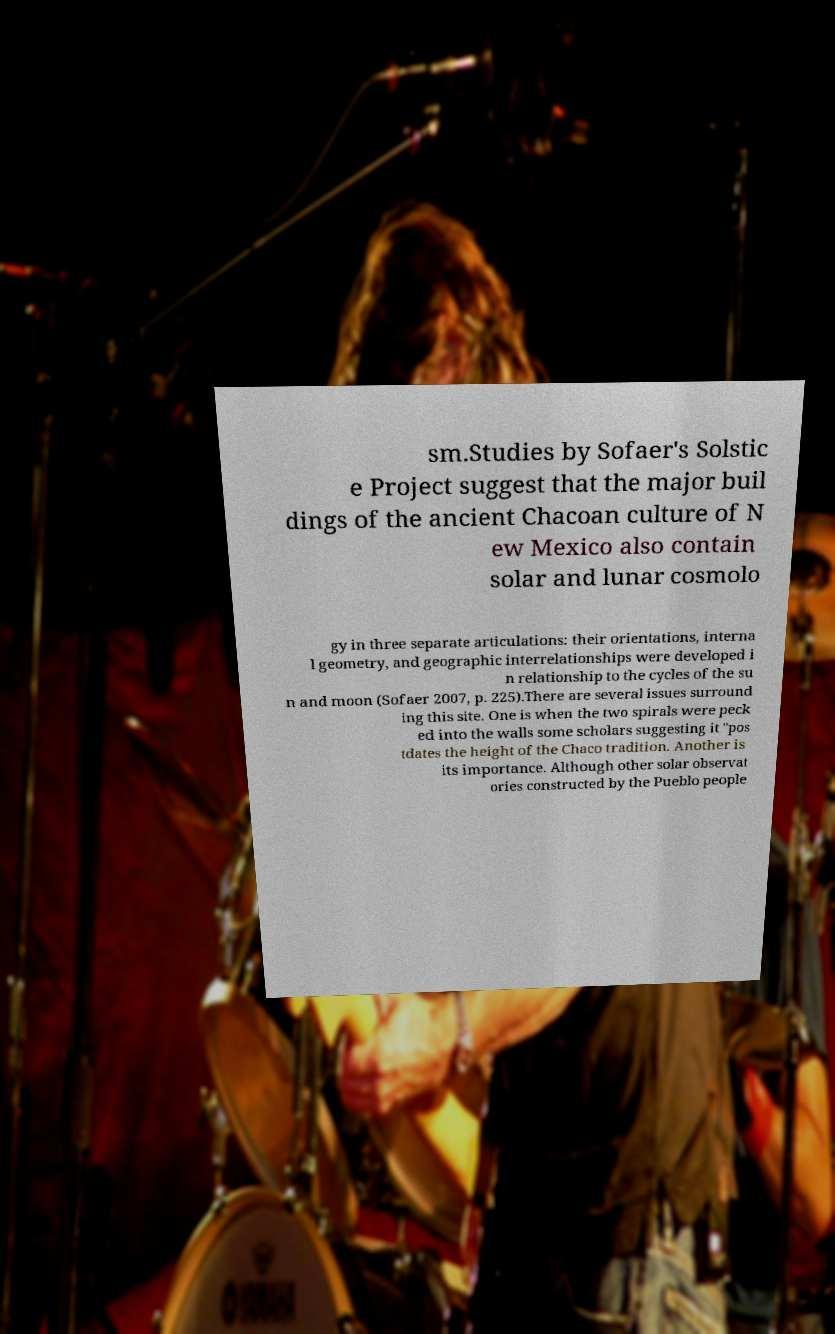There's text embedded in this image that I need extracted. Can you transcribe it verbatim? sm.Studies by Sofaer's Solstic e Project suggest that the major buil dings of the ancient Chacoan culture of N ew Mexico also contain solar and lunar cosmolo gy in three separate articulations: their orientations, interna l geometry, and geographic interrelationships were developed i n relationship to the cycles of the su n and moon (Sofaer 2007, p. 225).There are several issues surround ing this site. One is when the two spirals were peck ed into the walls some scholars suggesting it "pos tdates the height of the Chaco tradition. Another is its importance. Although other solar observat ories constructed by the Pueblo people 